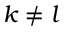Convert formula to latex. <formula><loc_0><loc_0><loc_500><loc_500>k \neq l</formula> 